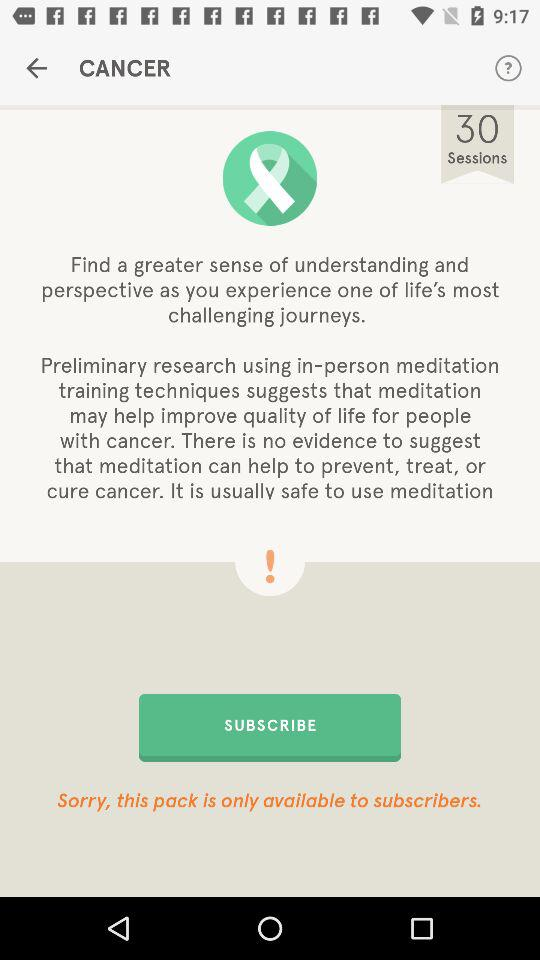The Pack is available for whom? The pack is available only to subcribers. 